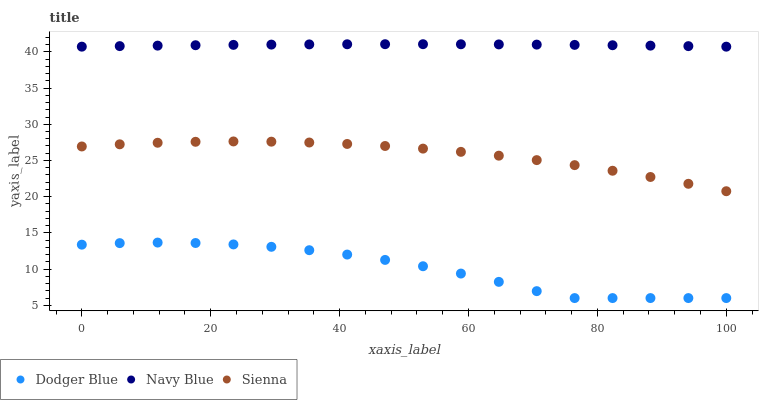Does Dodger Blue have the minimum area under the curve?
Answer yes or no. Yes. Does Navy Blue have the maximum area under the curve?
Answer yes or no. Yes. Does Navy Blue have the minimum area under the curve?
Answer yes or no. No. Does Dodger Blue have the maximum area under the curve?
Answer yes or no. No. Is Navy Blue the smoothest?
Answer yes or no. Yes. Is Dodger Blue the roughest?
Answer yes or no. Yes. Is Dodger Blue the smoothest?
Answer yes or no. No. Is Navy Blue the roughest?
Answer yes or no. No. Does Dodger Blue have the lowest value?
Answer yes or no. Yes. Does Navy Blue have the lowest value?
Answer yes or no. No. Does Navy Blue have the highest value?
Answer yes or no. Yes. Does Dodger Blue have the highest value?
Answer yes or no. No. Is Dodger Blue less than Sienna?
Answer yes or no. Yes. Is Navy Blue greater than Sienna?
Answer yes or no. Yes. Does Dodger Blue intersect Sienna?
Answer yes or no. No. 